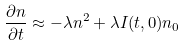<formula> <loc_0><loc_0><loc_500><loc_500>\frac { \partial n } { \partial t } \approx - \lambda n ^ { 2 } + \lambda I ( t , 0 ) n _ { 0 }</formula> 